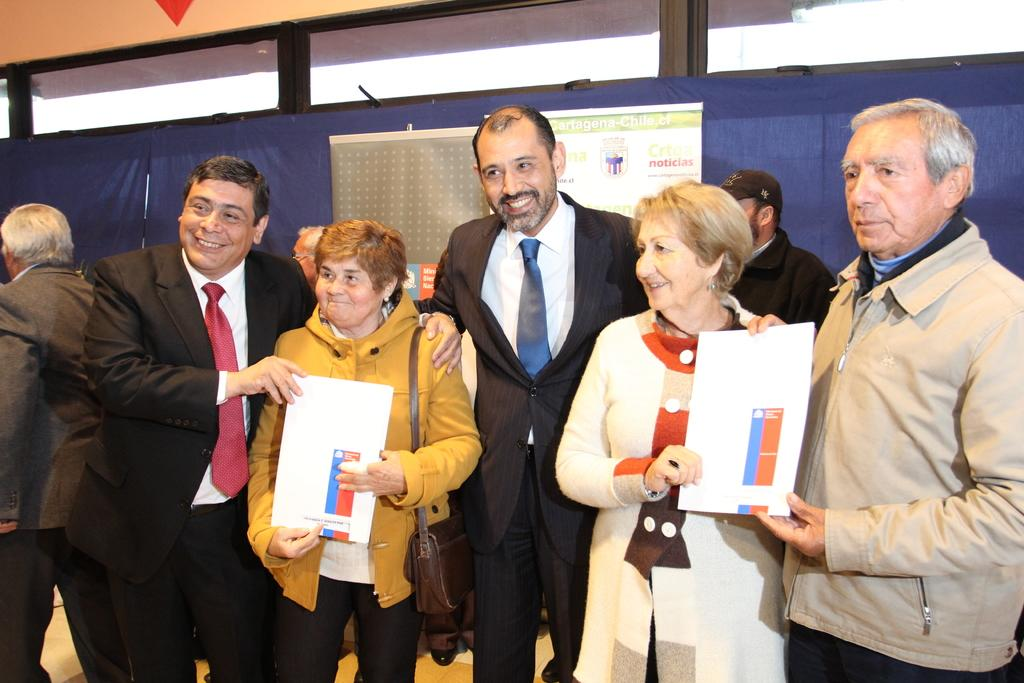How many people are in the image? There are people in the image, but the exact number is not specified. What are the people doing in the image? The people are standing and holding a certificate. Who might the people be looking at and smiling at? The people are looking and smiling at someone, but their identity is not mentioned. What type of bean is being used to power the appliance in the image? There is no bean or appliance present in the image. Can you tell me the name of the aunt who is standing next to the people in the image? There is no mention of an aunt or any other family members in the image. 